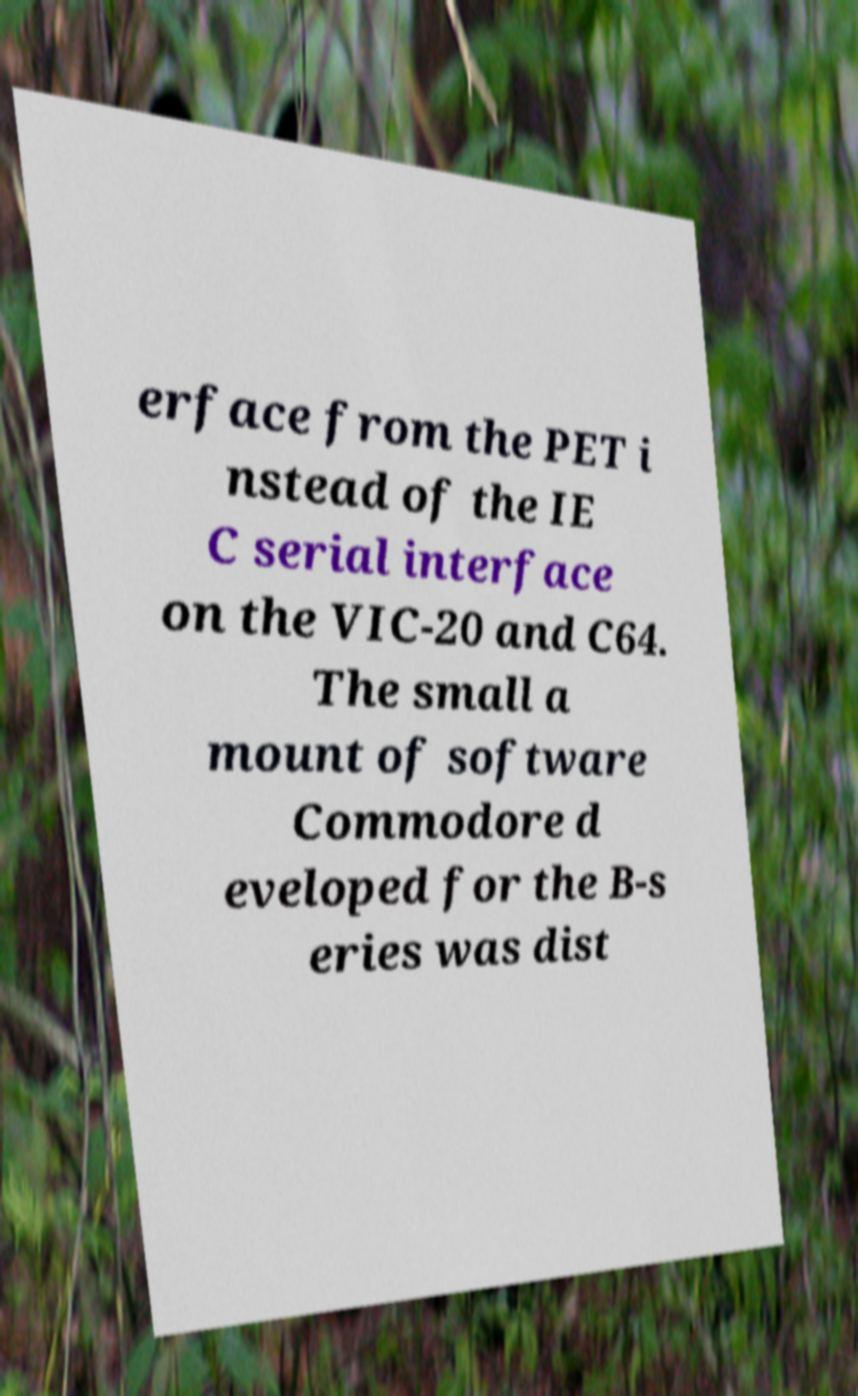Please read and relay the text visible in this image. What does it say? erface from the PET i nstead of the IE C serial interface on the VIC-20 and C64. The small a mount of software Commodore d eveloped for the B-s eries was dist 